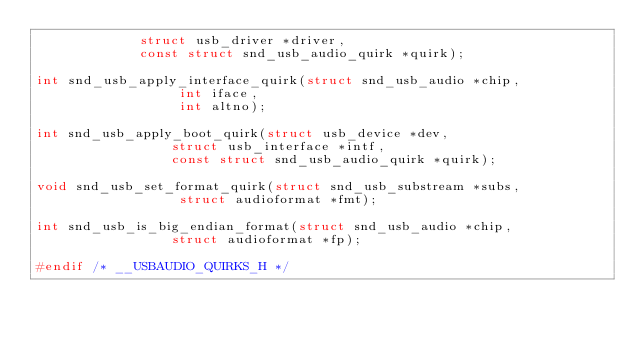Convert code to text. <code><loc_0><loc_0><loc_500><loc_500><_C_>			 struct usb_driver *driver,
			 const struct snd_usb_audio_quirk *quirk);

int snd_usb_apply_interface_quirk(struct snd_usb_audio *chip,
				  int iface,
				  int altno);

int snd_usb_apply_boot_quirk(struct usb_device *dev,
			     struct usb_interface *intf,
			     const struct snd_usb_audio_quirk *quirk);

void snd_usb_set_format_quirk(struct snd_usb_substream *subs,
			      struct audioformat *fmt);

int snd_usb_is_big_endian_format(struct snd_usb_audio *chip,
				 struct audioformat *fp);

#endif /* __USBAUDIO_QUIRKS_H */
</code> 